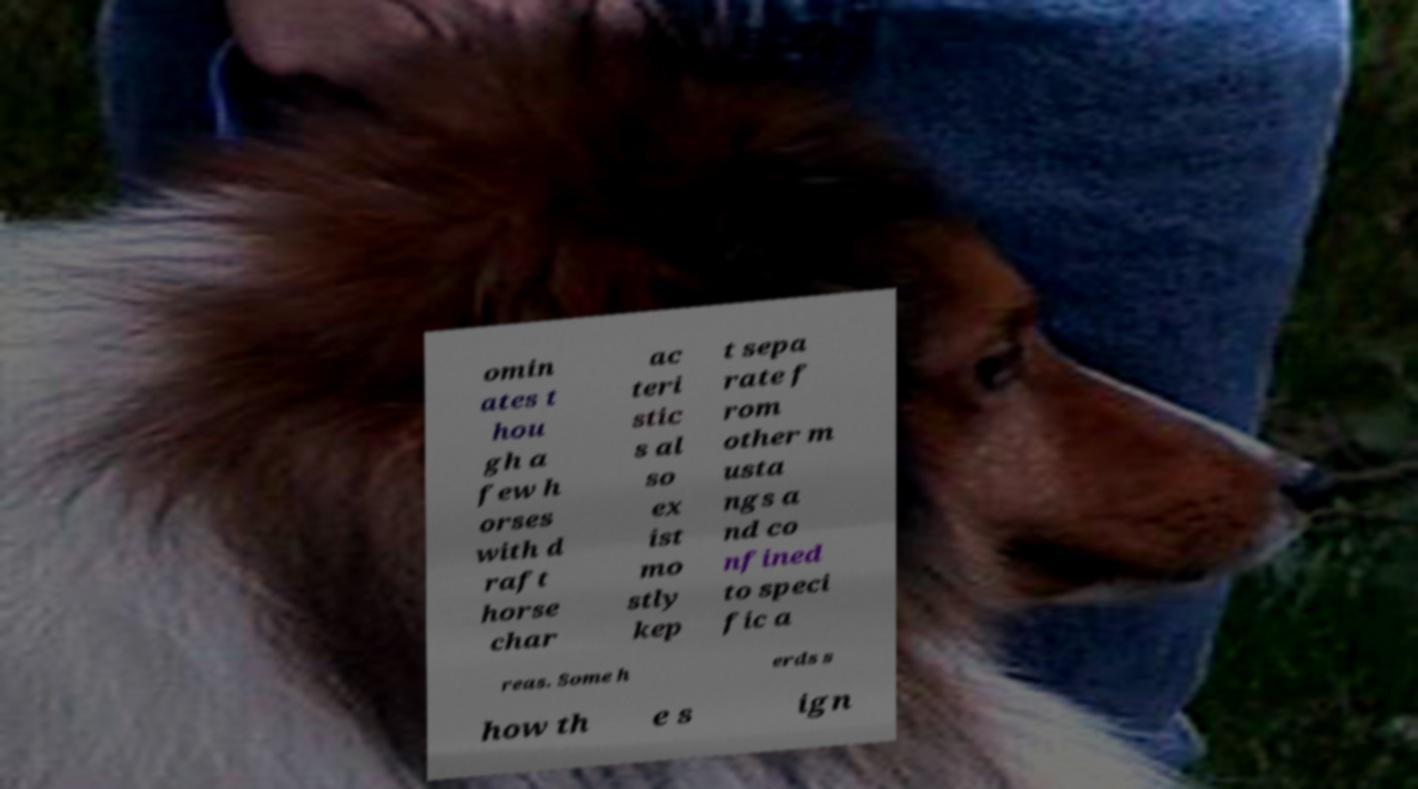For documentation purposes, I need the text within this image transcribed. Could you provide that? omin ates t hou gh a few h orses with d raft horse char ac teri stic s al so ex ist mo stly kep t sepa rate f rom other m usta ngs a nd co nfined to speci fic a reas. Some h erds s how th e s ign 